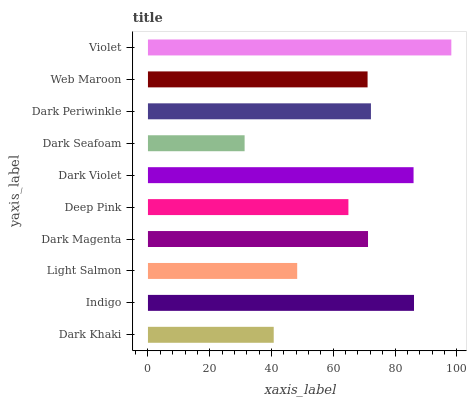Is Dark Seafoam the minimum?
Answer yes or no. Yes. Is Violet the maximum?
Answer yes or no. Yes. Is Indigo the minimum?
Answer yes or no. No. Is Indigo the maximum?
Answer yes or no. No. Is Indigo greater than Dark Khaki?
Answer yes or no. Yes. Is Dark Khaki less than Indigo?
Answer yes or no. Yes. Is Dark Khaki greater than Indigo?
Answer yes or no. No. Is Indigo less than Dark Khaki?
Answer yes or no. No. Is Dark Magenta the high median?
Answer yes or no. Yes. Is Web Maroon the low median?
Answer yes or no. Yes. Is Web Maroon the high median?
Answer yes or no. No. Is Dark Violet the low median?
Answer yes or no. No. 